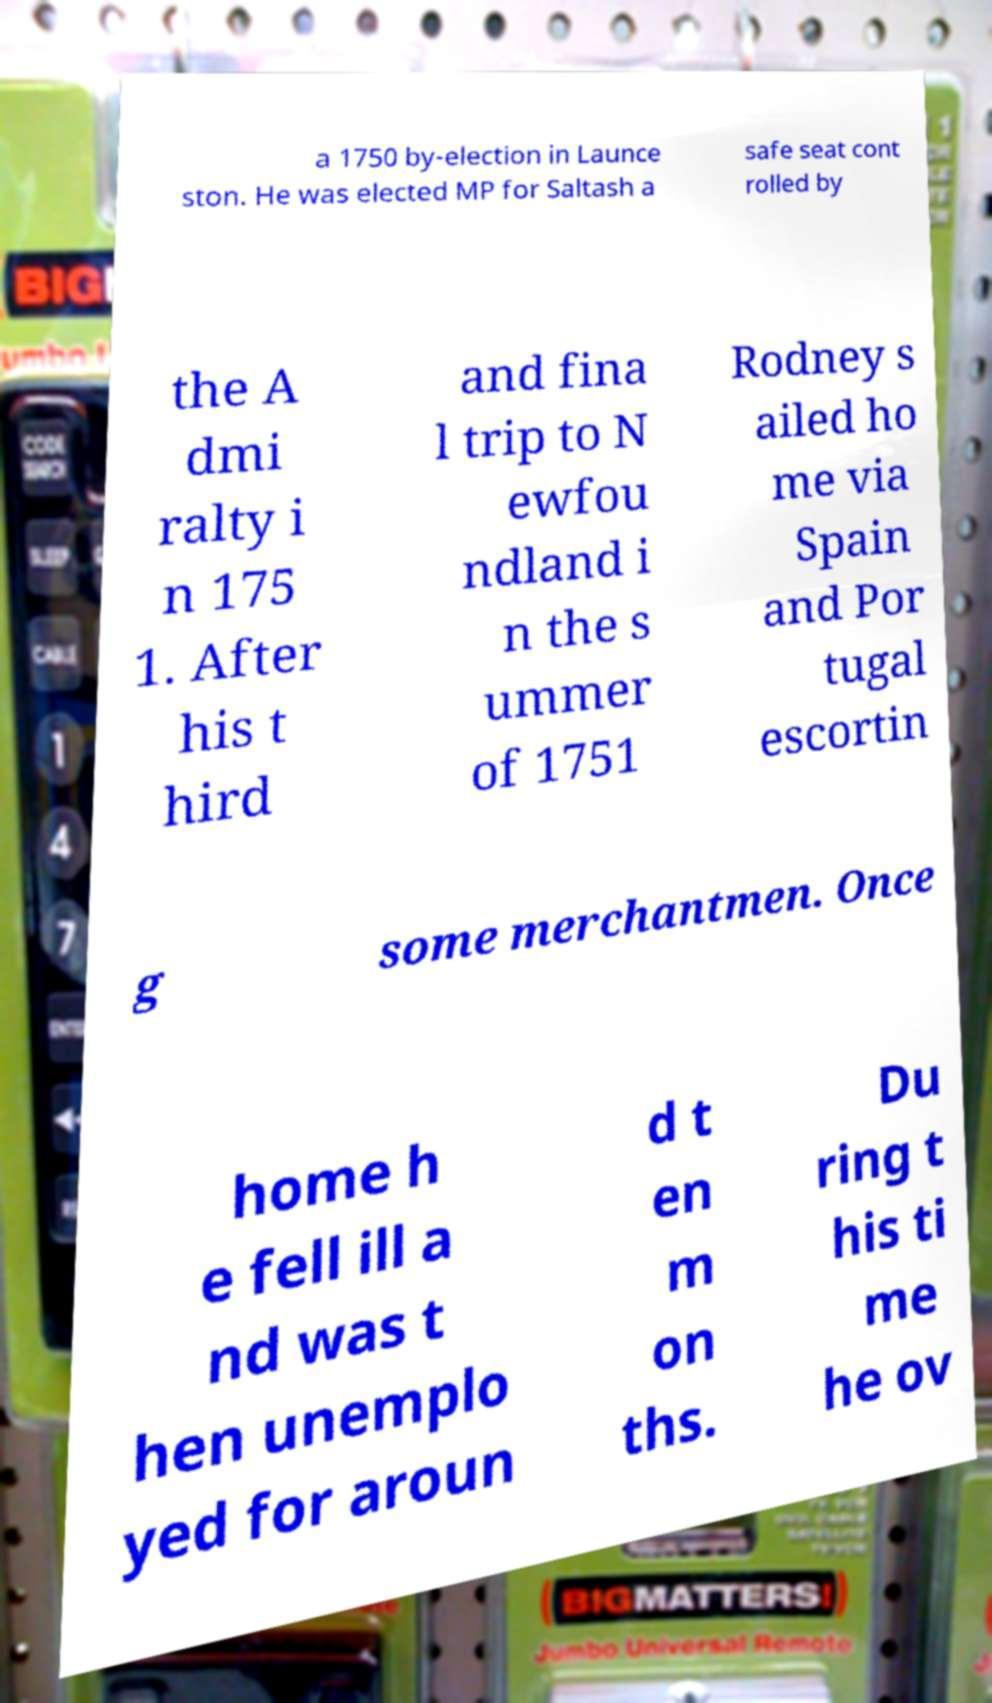There's text embedded in this image that I need extracted. Can you transcribe it verbatim? a 1750 by-election in Launce ston. He was elected MP for Saltash a safe seat cont rolled by the A dmi ralty i n 175 1. After his t hird and fina l trip to N ewfou ndland i n the s ummer of 1751 Rodney s ailed ho me via Spain and Por tugal escortin g some merchantmen. Once home h e fell ill a nd was t hen unemplo yed for aroun d t en m on ths. Du ring t his ti me he ov 